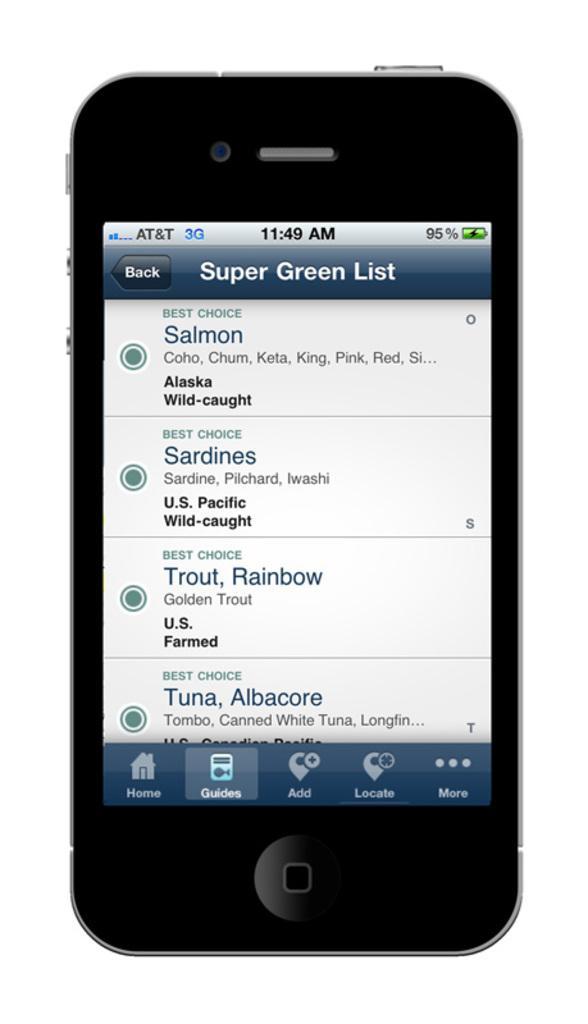Can you describe this image briefly? In the image there is a black color iPhone. To the bottom of the screen there are few icons like home, guides, locates and more in it. And to the top of the screen there is a time, battery symbol and signals symbols on it. Below that there is back button and another button. In middle of the mobile there is a list on the screen. 